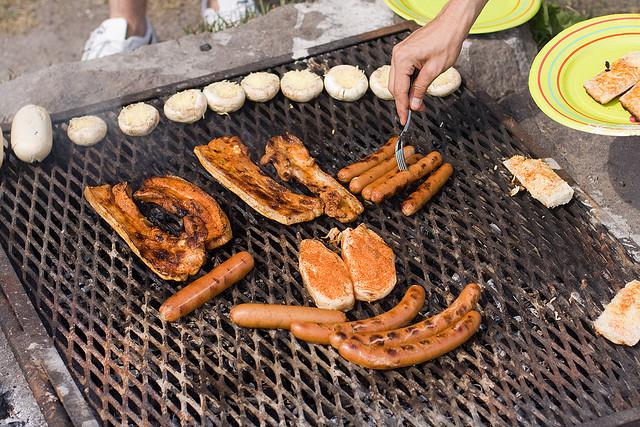What kind of grill is this?
Give a very brief answer. Barbecue. How many hot dogs to you see cooking?
Keep it brief. 10. What is at the top of the grill?
Give a very brief answer. Mushrooms. 